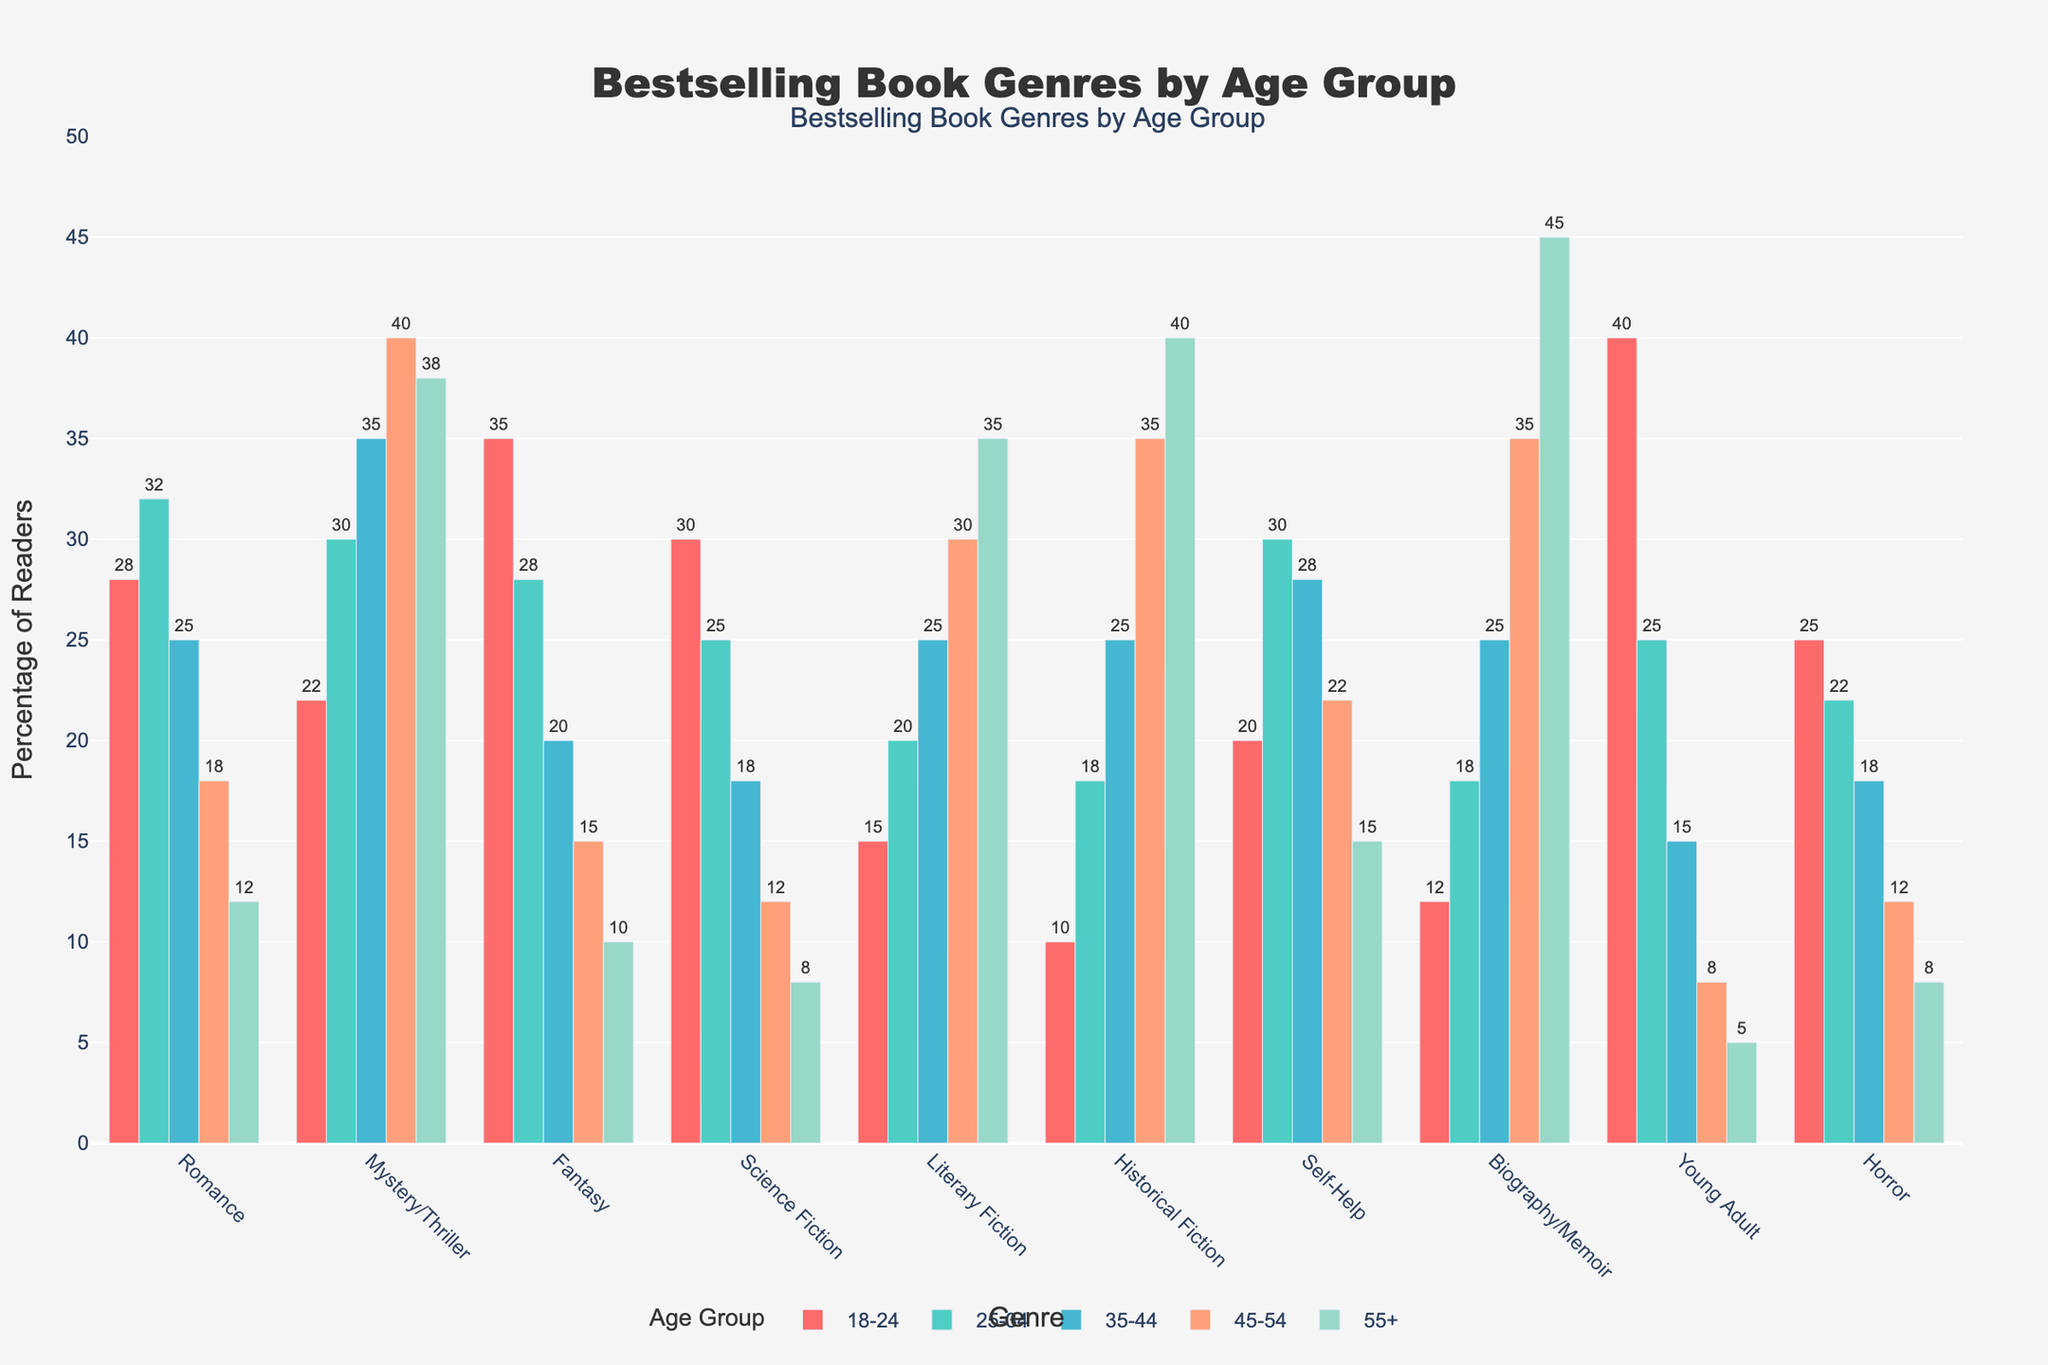What's the most popular genre among readers aged 18-24? We look at the bar heights for the age group 18-24. The highest bar represents the genre "Young Adult" with a value of 40.
Answer: Young Adult Which age group has the highest percentage of readers for the genre "Mystery/Thriller"? By comparing the bar heights for "Mystery/Thriller" across all age groups, the age group 45-54 has the highest value of 40.
Answer: 45-54 Does any genre have an equal percentage of readers across two different age groups? By examining each genre's value across all age groups, we see that no genre has the same percentage in two different age groups.
Answer: No How much more popular is Fantasy among 18-24 year-olds compared to 35-44 year-olds? Fantasy has values of 35 for 18-24 and 20 for 35-44. The difference is 35 - 20 = 15.
Answer: 15 What is the least popular genre among readers aged 55+? The shortest bar in the 55+ category represents the genre "Young Adult" with a value of 5.
Answer: Young Adult Which genre has the most even distribution among all age groups? Literary Fiction and Historical Fiction show increasing values with age, and their distribution seems relatively balanced across age groups compared to others.
Answer: Literary Fiction or Historical Fiction What percentage of readers aged 25-34 prefer Science Fiction compared to Romance? In the 25-34 age group, Science Fiction has a value of 25, and Romance has a value of 32. The percentage difference is 32 - 25 = 7.
Answer: 7 Which genre is equally popular among readers aged 25-34 and 35-44? Both Self-Help have similar values for 25-34 (30) and 35-44 (28), making Self-Help nearly equally popular.
Answer: Self-Help Compare the popularity of Biography/Memoir among readers aged 45-54 and 55+. Biography/Memoir is at 35 for ages 45-54 and 45 for 55+. The 55+ group has 10 more (45 - 35) readers compared to the 45-54 group.
Answer: 10 